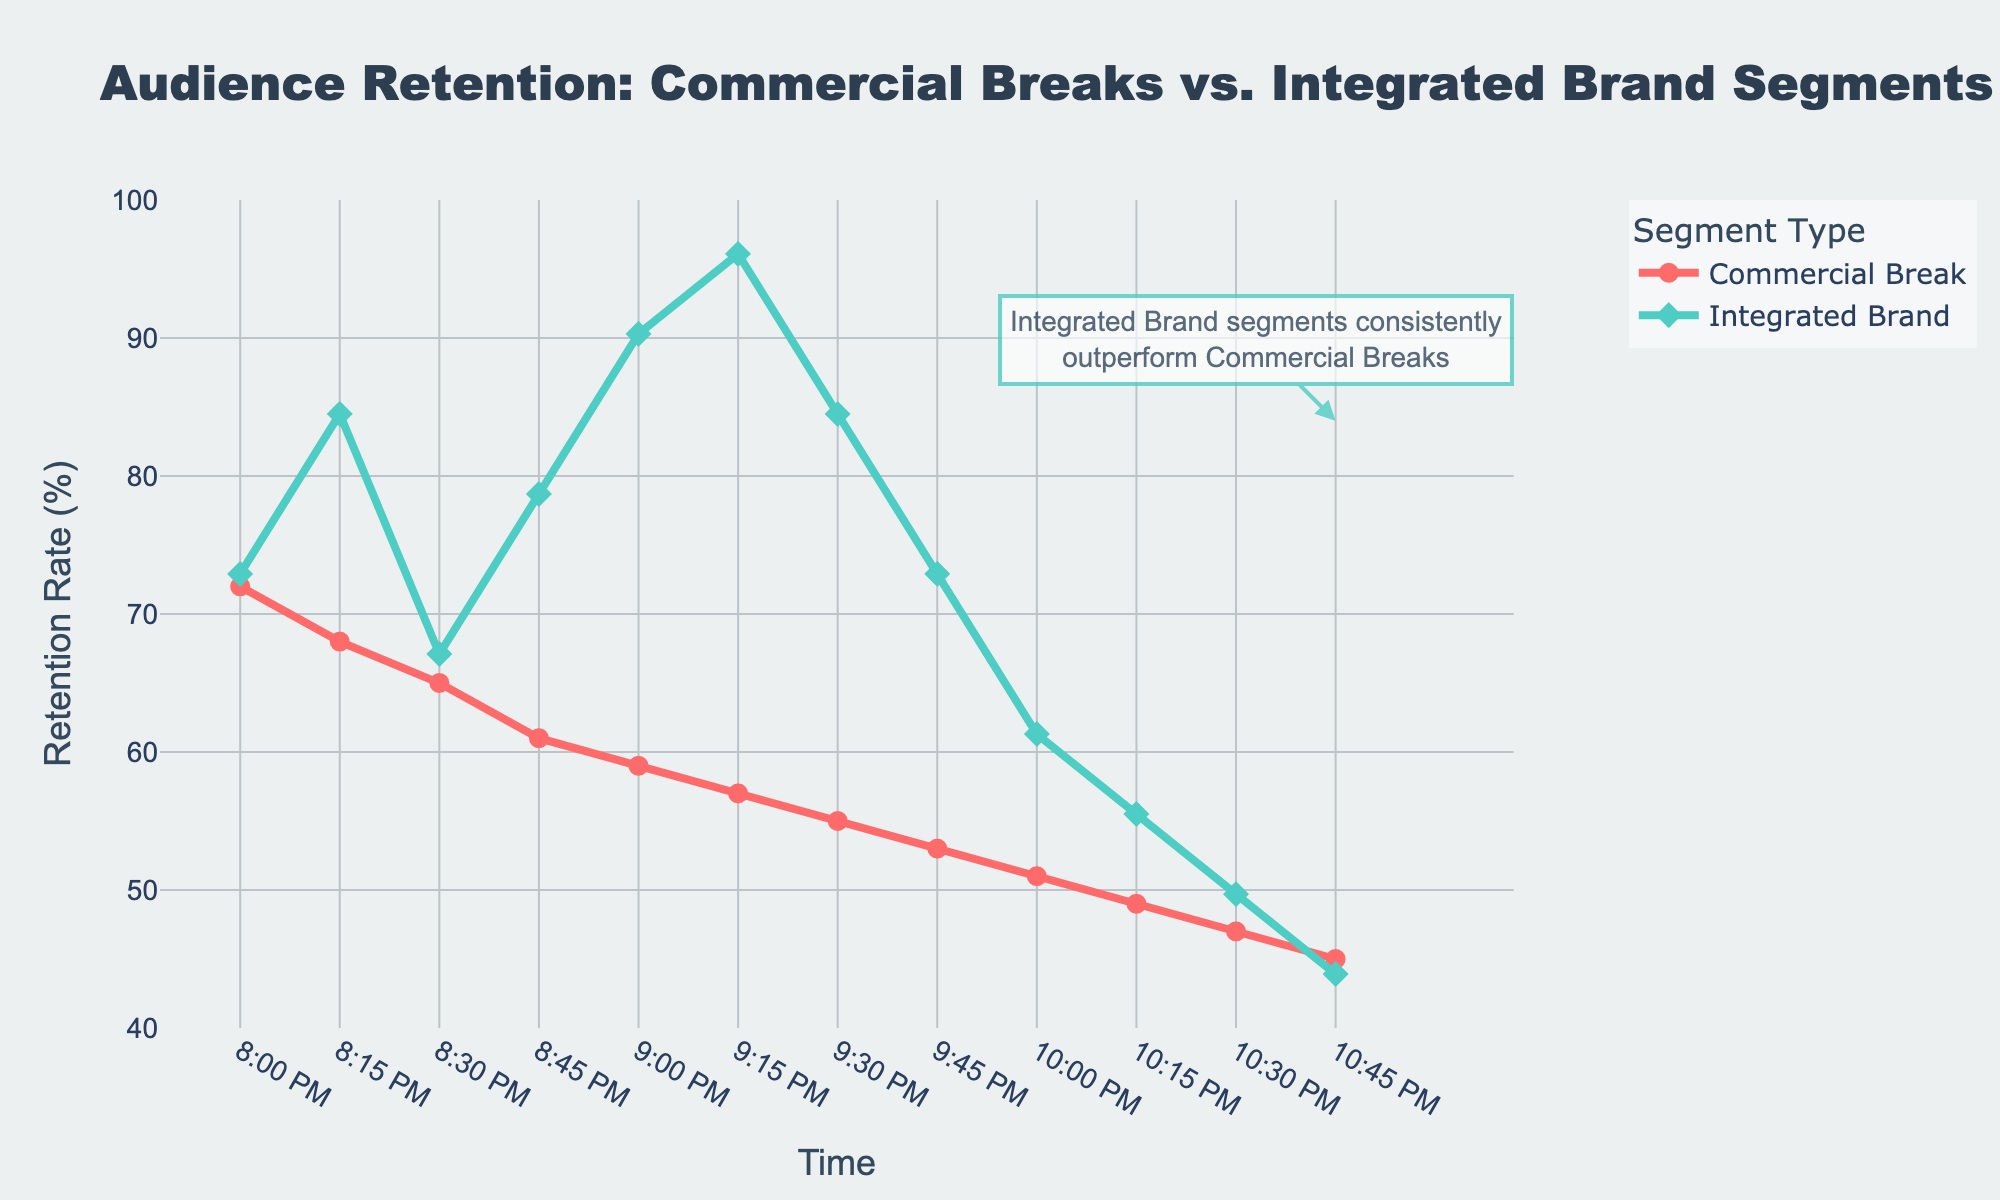Which time slot has the highest audience retention rate for both segment types? At 9:15 PM, the Integrated Brand Segment has a retention rate of 93%, which is the highest in the dataset, while the highest retention rate for Commercial Breaks is at 8:00 PM with 72%.
Answer: 9:15 PM for Integrated Brand Segment, 8:00 PM for Commercial Breaks By what percentage does the audience retention for integrated brand segments at 9:00 PM exceed that of commercial breaks at the same time? The audience retention rate for integrated brand segments at 9:00 PM is 92%, and for commercial breaks, it is 59%. The difference is 92% - 59% = 33%.
Answer: 33% What is the average retention rate difference between Commercial Breaks and Integrated Brand Segments at 8:00 PM and 9:00 PM? To find the average difference: 
1) At 8:00 PM: Integrated Brand Segment (89%) - Commercial Break (72%) = 17%
2) At 9:00 PM: Integrated Brand Segment (92%) - Commercial Break (59%) = 33%
Average difference = (17% + 33%) / 2 = 25%
Answer: 25% At which time slot is the retention rate difference between Commercial Breaks and Integrated Brand Segments the smallest? At 8:30 PM, Integrated Brand Segment retention is 88%, and Commercial Break retention is 65%. The difference of 23% is the smallest compared to other time slots.
Answer: 8:30 PM How does the trend of retention rates for Integrated Brand Segments compare to Commercial Breaks over time? The retention rate for Integrated Brand Segments remains consistently higher and relatively stable, while the retention rate for Commercial Breaks shows a gradual decline over time.
Answer: Integrated Brand Segments consistently higher and stable; Commercial Breaks decline Which segment type shows a greater retention decline over the entire time period? The Commercial Break retention rate decreases from 72% to 45%, a decline of 27%. The Integrated Brand Segment retention rate decreases from 89% to 84%, a decline of 5%. Therefore, Commercial Break retention shows a greater decline.
Answer: Commercial Breaks Calculate the average retention rate for integrated brand segments over the 4 hours. Sum the retention rates for Integrated Brand Segments: 89% + 91% + 88% + 90% + 92% + 93% + 91% + 89% + 87% + 86% + 85% + 84% = 1065. Divide by 12 data points: 1065 / 12 = 88.75%
Answer: 88.75% What can you infer from the annotation in the figure? The annotation points out that "Integrated Brand segments consistently outperform Commercial Breaks," suggesting that integrated brand segments maintain higher retention rates throughout the time period.
Answer: Integrated Brand segments always have higher retention What is the total retention rate for commercial breaks from 8:00 PM to 9:00 PM? Sum of the retention rates for Commercial Breaks from 8:00 PM to 9:00 PM: 72% + 68% + 65% + 61% + 59% = 325%.
Answer: 325% 